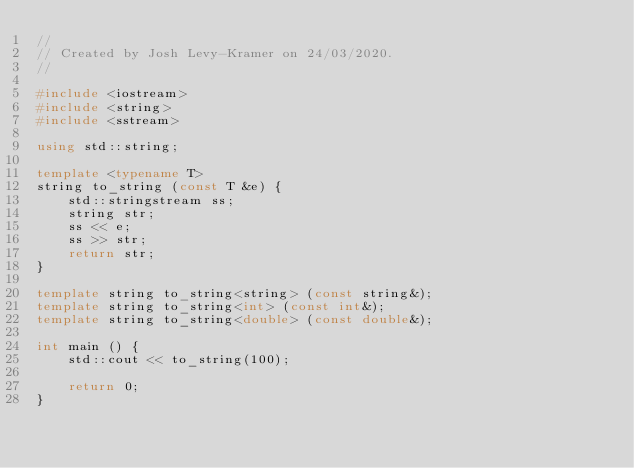Convert code to text. <code><loc_0><loc_0><loc_500><loc_500><_C++_>//
// Created by Josh Levy-Kramer on 24/03/2020.
//

#include <iostream>
#include <string>
#include <sstream>

using std::string;

template <typename T>
string to_string (const T &e) {
    std::stringstream ss;
    string str;
    ss << e;
    ss >> str;
    return str;
}

template string to_string<string> (const string&);
template string to_string<int> (const int&);
template string to_string<double> (const double&);

int main () {
    std::cout << to_string(100);

    return 0;
}</code> 